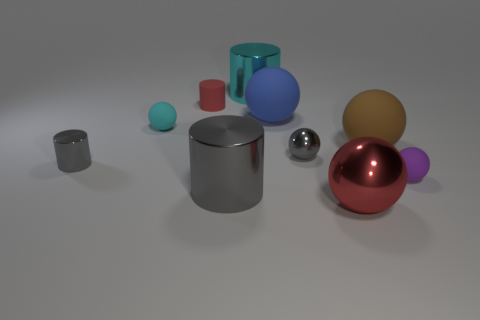What number of gray cylinders are the same size as the red rubber cylinder?
Your answer should be compact. 1. The large metallic object that is the same color as the small rubber cylinder is what shape?
Your answer should be compact. Sphere. How many things are either matte things in front of the cyan sphere or small cylinders?
Ensure brevity in your answer.  4. Are there fewer red metallic balls than brown cylinders?
Provide a short and direct response. No. The big brown object that is the same material as the red cylinder is what shape?
Keep it short and to the point. Sphere. There is a small purple matte object; are there any large brown spheres left of it?
Give a very brief answer. Yes. Is the number of large blue balls that are in front of the brown matte object less than the number of small red cylinders?
Offer a very short reply. Yes. What is the blue ball made of?
Your response must be concise. Rubber. What is the color of the small metallic ball?
Keep it short and to the point. Gray. What is the color of the big thing that is behind the tiny purple matte thing and in front of the big blue object?
Your answer should be very brief. Brown. 